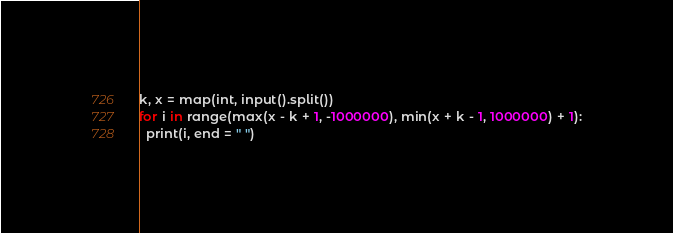Convert code to text. <code><loc_0><loc_0><loc_500><loc_500><_Python_>k, x = map(int, input().split())
for i in range(max(x - k + 1, -1000000), min(x + k - 1, 1000000) + 1):
  print(i, end = " ")</code> 